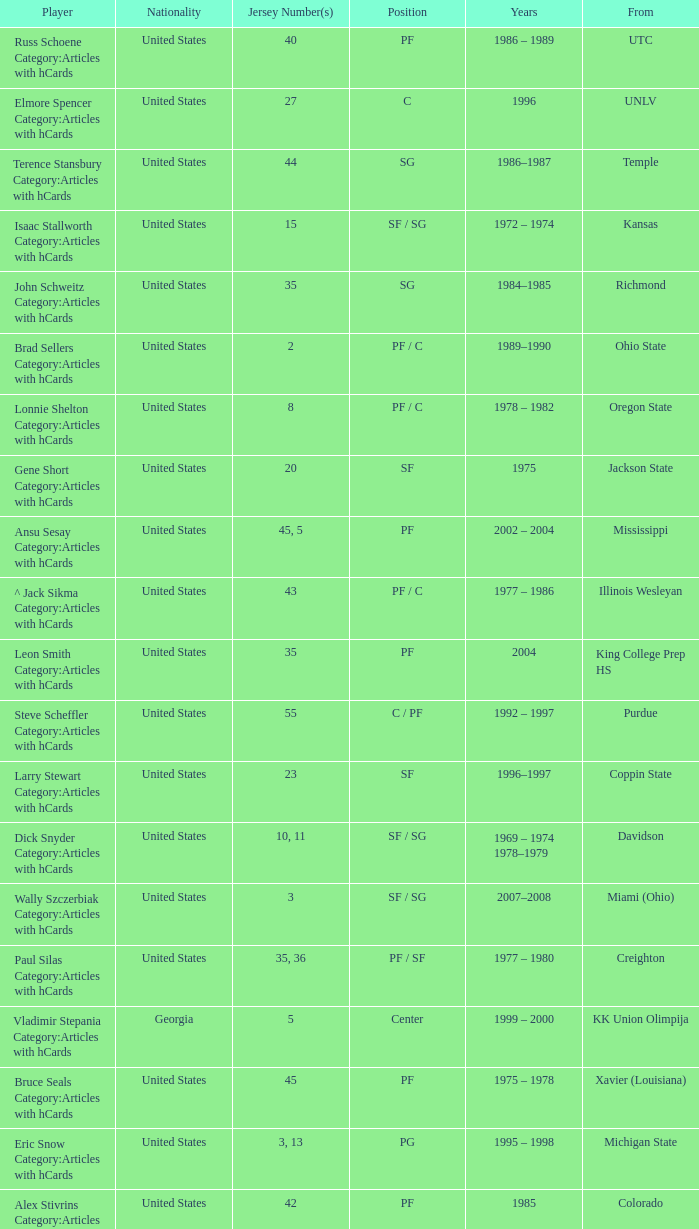What position does the player with jersey number 22 play? SF / SG. 